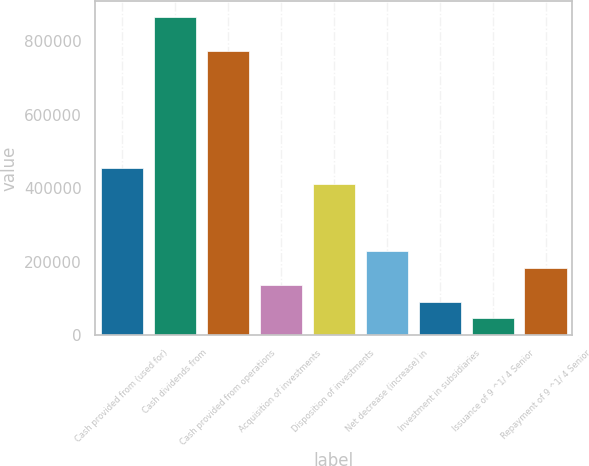<chart> <loc_0><loc_0><loc_500><loc_500><bar_chart><fcel>Cash provided from (used for)<fcel>Cash dividends from<fcel>Cash provided from operations<fcel>Acquisition of investments<fcel>Disposition of investments<fcel>Net decrease (increase) in<fcel>Investment in subsidiaries<fcel>Issuance of 9 ^1/ 4 Senior<fcel>Repayment of 9 ^1/ 4 Senior<nl><fcel>455736<fcel>865897<fcel>774750<fcel>136722<fcel>410162<fcel>227869<fcel>91148.1<fcel>45574.6<fcel>182295<nl></chart> 